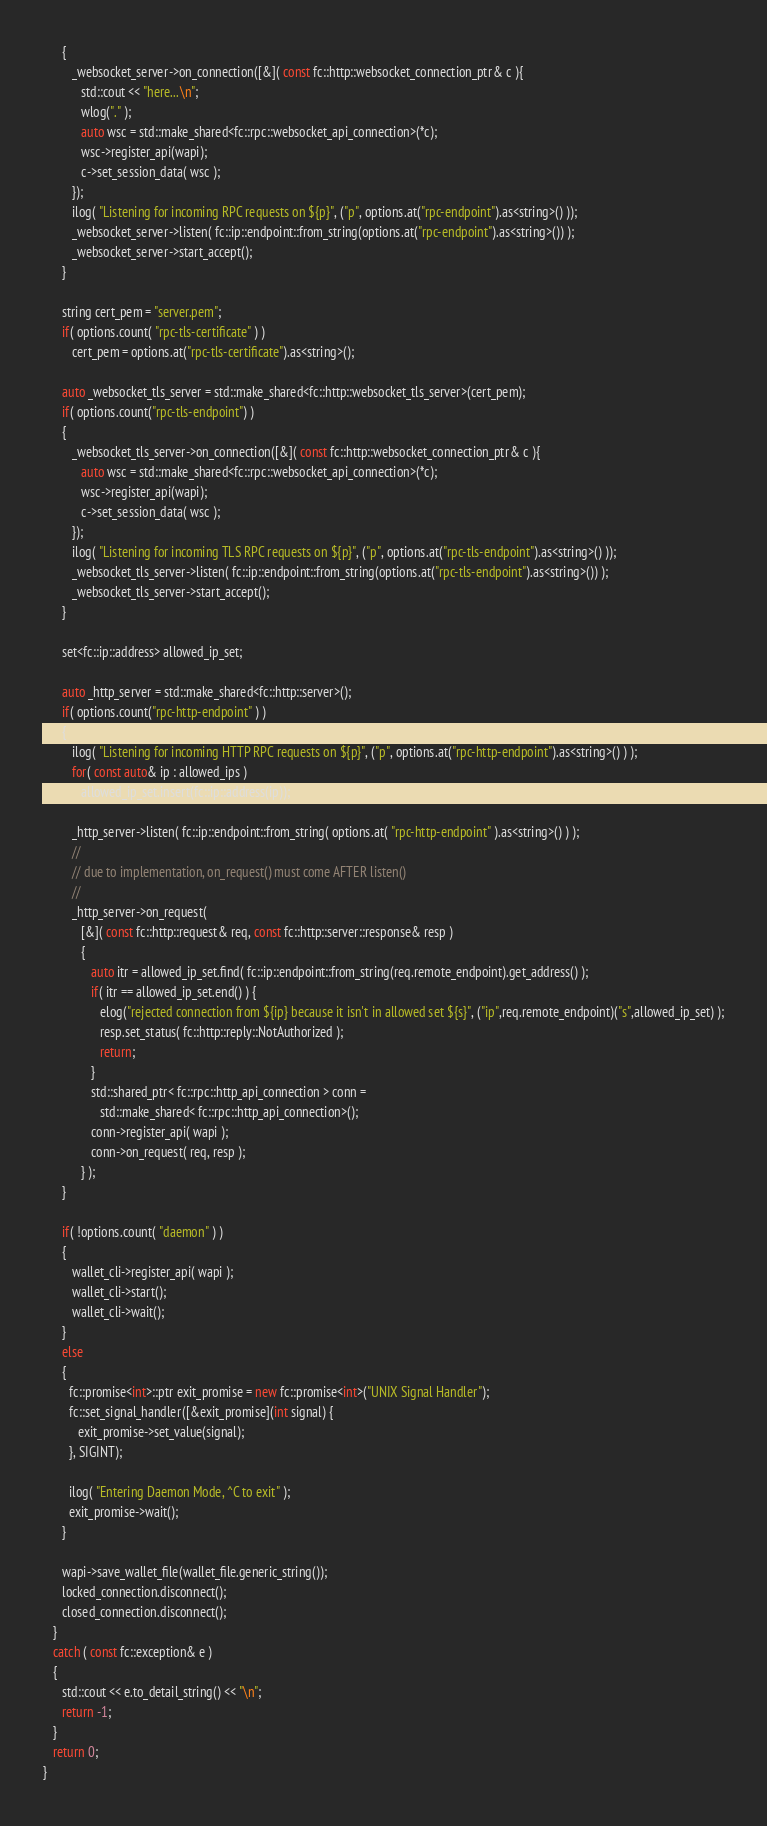<code> <loc_0><loc_0><loc_500><loc_500><_C++_>      {
         _websocket_server->on_connection([&]( const fc::http::websocket_connection_ptr& c ){
            std::cout << "here... \n";
            wlog("." );
            auto wsc = std::make_shared<fc::rpc::websocket_api_connection>(*c);
            wsc->register_api(wapi);
            c->set_session_data( wsc );
         });
         ilog( "Listening for incoming RPC requests on ${p}", ("p", options.at("rpc-endpoint").as<string>() ));
         _websocket_server->listen( fc::ip::endpoint::from_string(options.at("rpc-endpoint").as<string>()) );
         _websocket_server->start_accept();
      }

      string cert_pem = "server.pem";
      if( options.count( "rpc-tls-certificate" ) )
         cert_pem = options.at("rpc-tls-certificate").as<string>();

      auto _websocket_tls_server = std::make_shared<fc::http::websocket_tls_server>(cert_pem);
      if( options.count("rpc-tls-endpoint") )
      {
         _websocket_tls_server->on_connection([&]( const fc::http::websocket_connection_ptr& c ){
            auto wsc = std::make_shared<fc::rpc::websocket_api_connection>(*c);
            wsc->register_api(wapi);
            c->set_session_data( wsc );
         });
         ilog( "Listening for incoming TLS RPC requests on ${p}", ("p", options.at("rpc-tls-endpoint").as<string>() ));
         _websocket_tls_server->listen( fc::ip::endpoint::from_string(options.at("rpc-tls-endpoint").as<string>()) );
         _websocket_tls_server->start_accept();
      }

      set<fc::ip::address> allowed_ip_set;

      auto _http_server = std::make_shared<fc::http::server>();
      if( options.count("rpc-http-endpoint" ) )
      {
         ilog( "Listening for incoming HTTP RPC requests on ${p}", ("p", options.at("rpc-http-endpoint").as<string>() ) );
         for( const auto& ip : allowed_ips )
            allowed_ip_set.insert(fc::ip::address(ip));

         _http_server->listen( fc::ip::endpoint::from_string( options.at( "rpc-http-endpoint" ).as<string>() ) );
         //
         // due to implementation, on_request() must come AFTER listen()
         //
         _http_server->on_request(
            [&]( const fc::http::request& req, const fc::http::server::response& resp )
            {
               auto itr = allowed_ip_set.find( fc::ip::endpoint::from_string(req.remote_endpoint).get_address() );
               if( itr == allowed_ip_set.end() ) {
                  elog("rejected connection from ${ip} because it isn't in allowed set ${s}", ("ip",req.remote_endpoint)("s",allowed_ip_set) );
                  resp.set_status( fc::http::reply::NotAuthorized );
                  return;
               }
               std::shared_ptr< fc::rpc::http_api_connection > conn =
                  std::make_shared< fc::rpc::http_api_connection>();
               conn->register_api( wapi );
               conn->on_request( req, resp );
            } );
      }

      if( !options.count( "daemon" ) )
      {
         wallet_cli->register_api( wapi );
         wallet_cli->start();
         wallet_cli->wait();
      }
      else
      {
        fc::promise<int>::ptr exit_promise = new fc::promise<int>("UNIX Signal Handler");
        fc::set_signal_handler([&exit_promise](int signal) {
           exit_promise->set_value(signal);
        }, SIGINT);

        ilog( "Entering Daemon Mode, ^C to exit" );
        exit_promise->wait();
      }

      wapi->save_wallet_file(wallet_file.generic_string());
      locked_connection.disconnect();
      closed_connection.disconnect();
   }
   catch ( const fc::exception& e )
   {
      std::cout << e.to_detail_string() << "\n";
      return -1;
   }
   return 0;
}
</code> 